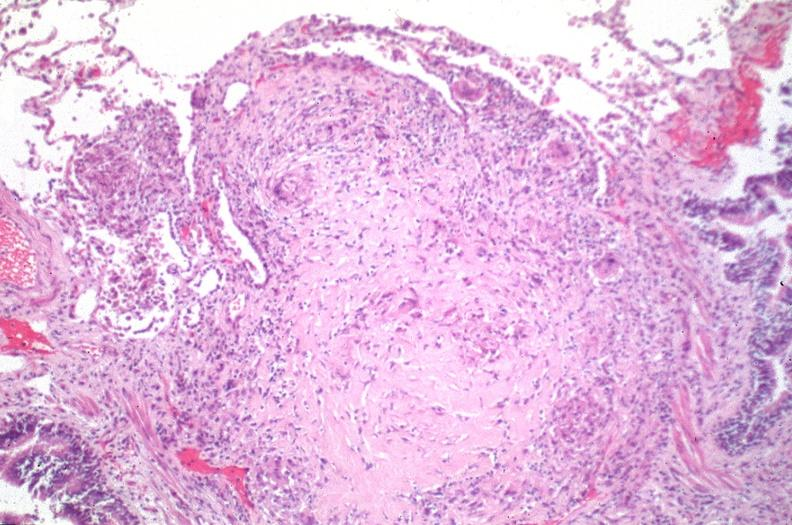what does this image show?
Answer the question using a single word or phrase. Lung 